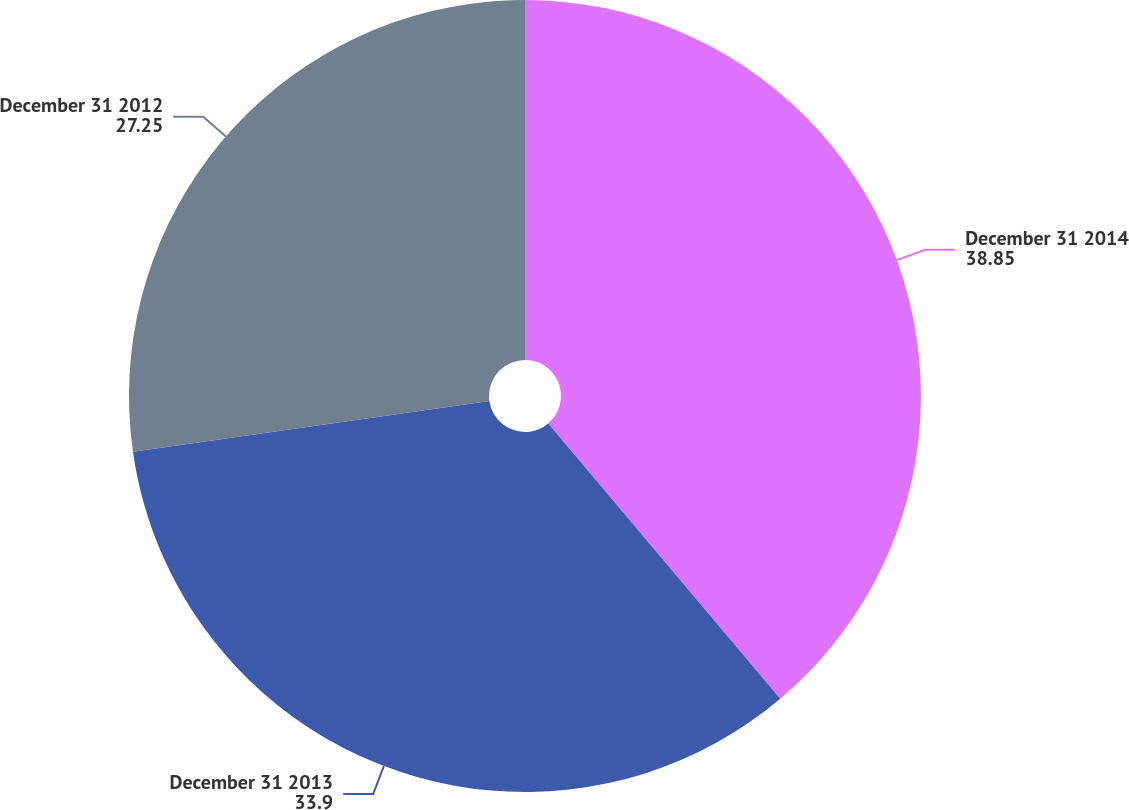Convert chart to OTSL. <chart><loc_0><loc_0><loc_500><loc_500><pie_chart><fcel>December 31 2014<fcel>December 31 2013<fcel>December 31 2012<nl><fcel>38.85%<fcel>33.9%<fcel>27.25%<nl></chart> 